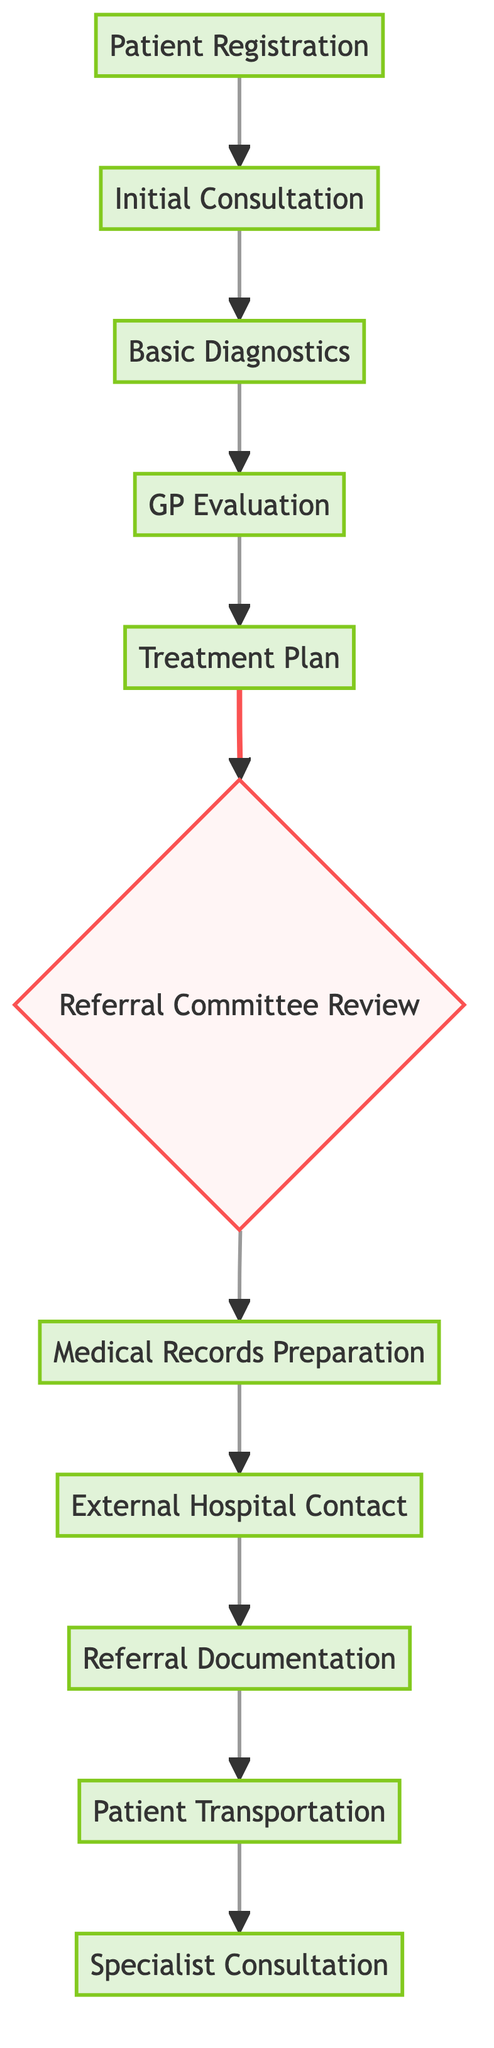What is the first step in the patient referral process? The first step in the patient referral process is "Patient Registration," which is the starting point for all patients seeking care. This node is at the top of the diagram, indicating its primacy.
Answer: Patient Registration How many total nodes are represented in the diagram? The diagram contains a total of 11 nodes, as counted by identifying each unique step or point in the patient referral process.
Answer: 11 Which two nodes indicate the submission and approval of a referral? The nodes relevant for this process are "Treatment Plan," where the referral proposal is submitted, and "Referral Committee Review," which indicates the approval of that referral. They directly indicate these actions in the sequence of the diagram.
Answer: Treatment Plan, Referral Committee Review What does the node "Basic Diagnostics" provide for the next stage? "Basic Diagnostics" provides results that are necessary for the "GP Evaluation." This direct relationship is indicated in the flow of the diagram, showing the progression from diagnostics to evaluation.
Answer: Provides results What happens after "Medical Records Preparation"? After "Medical Records Preparation," the next stage in the referral process is "External Hospital Contact." This sequential flow is shown as the preparation of records leads directly to contacting the external hospital for further actions.
Answer: External Hospital Contact What is indicated by the edges between "Referral Committee Review" and "Medical Records Preparation"? The edge indicates that once the referral is approved at the "Referral Committee Review," it leads to "Medical Records Preparation." This directional flow signifies that the approval must first occur before records can be prepared.
Answer: Approves referral How many edges connect to the "Specialist Consultation" node? The "Specialist Consultation" node has one incoming edge that connects from "Patient Transportation," indicating that this is the sole precursor to consulting with the specialist.
Answer: 1 What is the final step in the patient referral process? The final step in the patient referral process is "Specialist Consultation," where the patient receives care from a specialist after all the previous steps have been completed.
Answer: Specialist Consultation Which step leads to the arrangement of patient transportation? The step that leads to the arrangement of patient transportation is "Referral Documentation." This edge shows that the finalizing of documentation directly influences the arrangement of transport for the patient.
Answer: Referral Documentation 